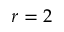<formula> <loc_0><loc_0><loc_500><loc_500>r = 2</formula> 